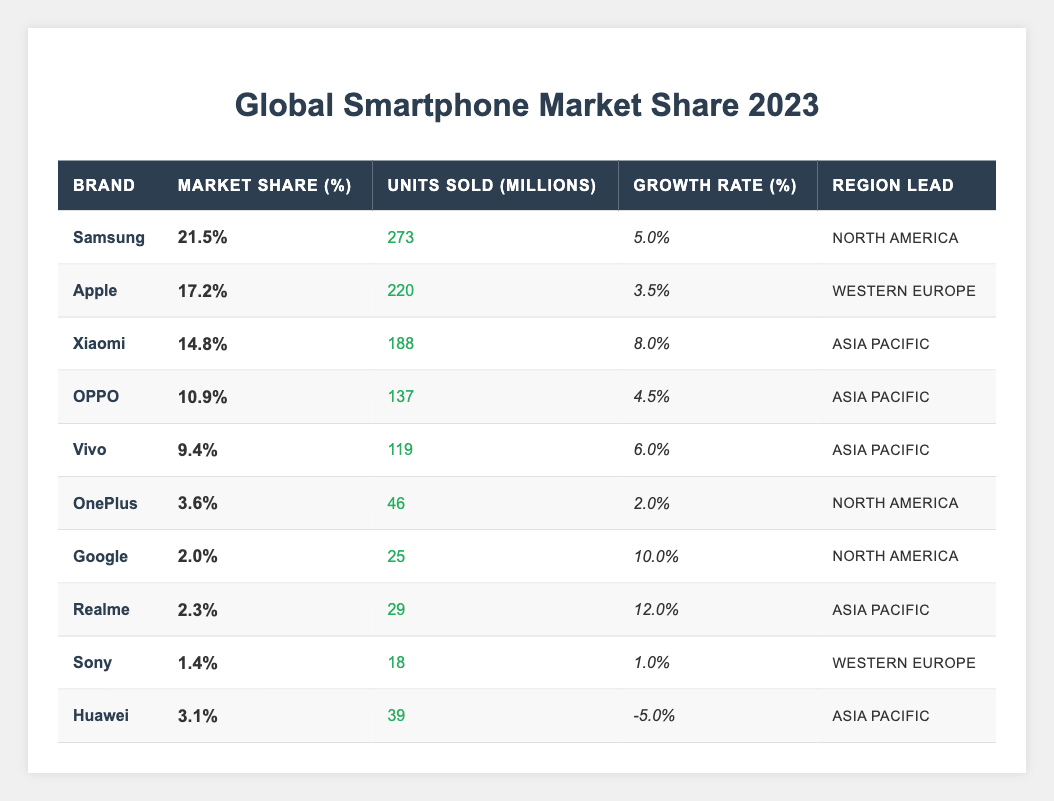What is the market share percentage of Samsung? The data in the table under the "Market Share (%)" column for Samsung shows 21.5%.
Answer: 21.5% Which brand sold the least number of units in millions? By examining the "Units Sold (Millions)" column, Google sold 25 million units, which is the lowest among all brands listed.
Answer: Google What is the total market share percentage of all brands listed in the table? Adding up the market share percentages: 21.5 + 17.2 + 14.8 + 10.9 + 9.4 + 3.6 + 2.0 + 2.3 + 1.4 + 3.1 = 84.8%.
Answer: 84.8% Is the growth rate for Xiaomi higher than that of Apple? The growth rate for Xiaomi is 8.0%, while Apple's is 3.5%. Since 8.0% is greater than 3.5%, the statement is true.
Answer: Yes What is the average growth rate of all brands? To find the average, we sum the growth rates: 5.0 + 3.5 + 8.0 + 4.5 + 6.0 + 2.0 + 10.0 + 12.0 + 1.0 - 5.0 = 42.0%. Then we divide by the number of brands (10): 42.0% / 10 = 4.2%.
Answer: 4.2% Which brand has the largest market share growth rate, and what is it? Comparing all the growth rates, Realme has the highest rate of 12.0%.
Answer: Realme, 12.0% What is the difference in market share percentage between Samsung and Apple? Samsung has a market share of 21.5% and Apple has 17.2%. The difference is 21.5% - 17.2% = 4.3%.
Answer: 4.3% Which brand leads in the Asia Pacific region? The brands leading in Asia Pacific are Xiaomi, OPPO, Vivo, and Realme. Xiaomi has the highest market share at 14.8%.
Answer: Xiaomi What percentage of the total units sold did Samsung contribute? Samsung sold 273 million units out of a total of (273 + 220 + 188 + 137 + 119 + 46 + 25 + 29 + 18 + 39 = 1,194 million). The percentage is (273 / 1,194) * 100 = 22.8%.
Answer: 22.8% Is Vivo's market share greater than Huawei's? Vivo's market share is 9.4%, while Huawei's is 3.1%. Since 9.4% is greater than 3.1%, the statement is true.
Answer: Yes 